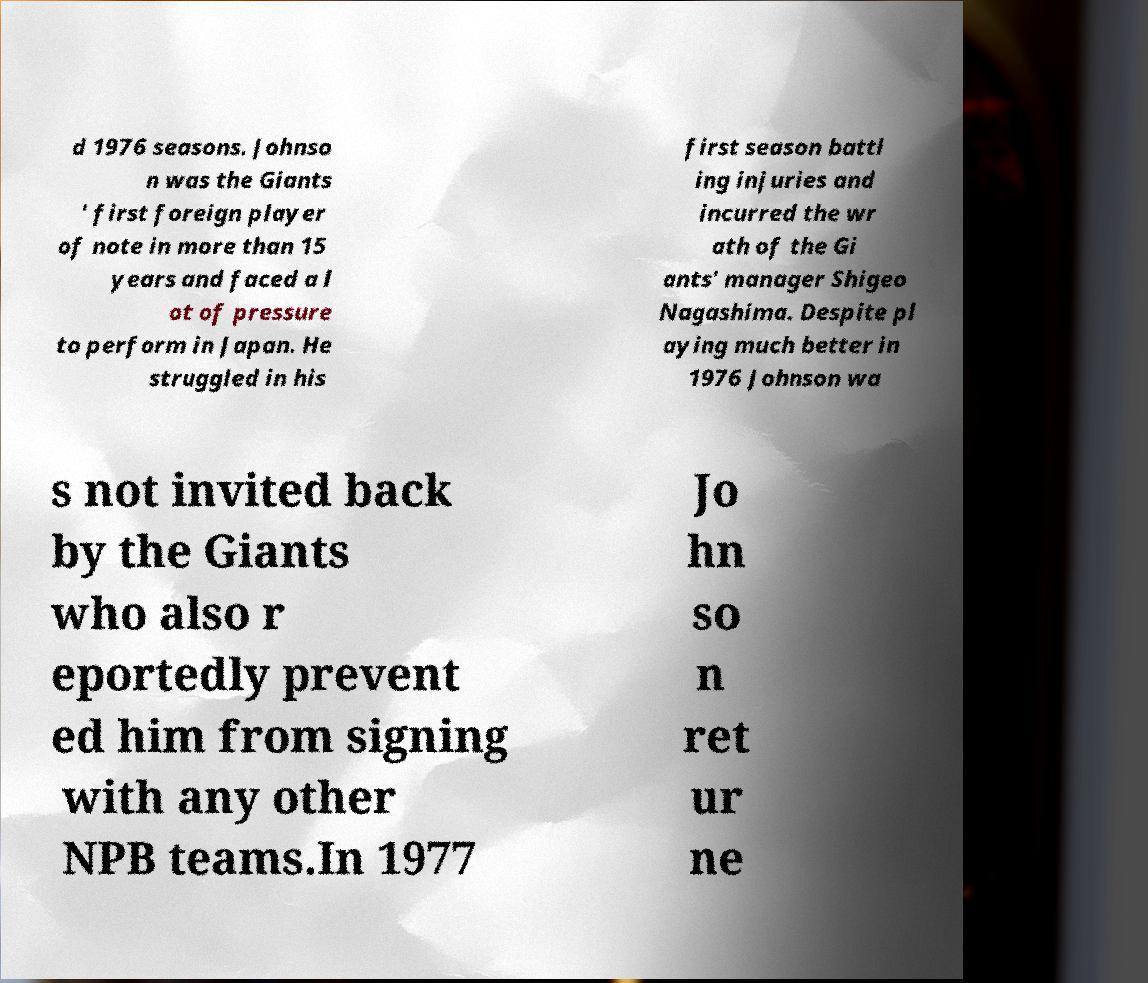Could you assist in decoding the text presented in this image and type it out clearly? d 1976 seasons. Johnso n was the Giants ' first foreign player of note in more than 15 years and faced a l ot of pressure to perform in Japan. He struggled in his first season battl ing injuries and incurred the wr ath of the Gi ants' manager Shigeo Nagashima. Despite pl aying much better in 1976 Johnson wa s not invited back by the Giants who also r eportedly prevent ed him from signing with any other NPB teams.In 1977 Jo hn so n ret ur ne 